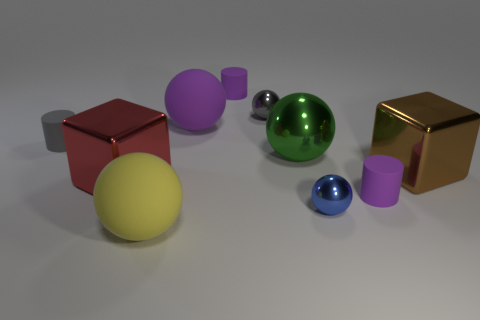Subtract all metallic balls. How many balls are left? 2 Subtract 1 spheres. How many spheres are left? 4 Subtract all gray cylinders. How many cylinders are left? 2 Add 3 purple rubber cylinders. How many purple rubber cylinders exist? 5 Subtract 0 blue cylinders. How many objects are left? 10 Subtract all blocks. How many objects are left? 8 Subtract all purple spheres. Subtract all cyan blocks. How many spheres are left? 4 Subtract all purple blocks. How many purple cylinders are left? 2 Subtract all spheres. Subtract all big red shiny things. How many objects are left? 4 Add 9 small blue metallic things. How many small blue metallic things are left? 10 